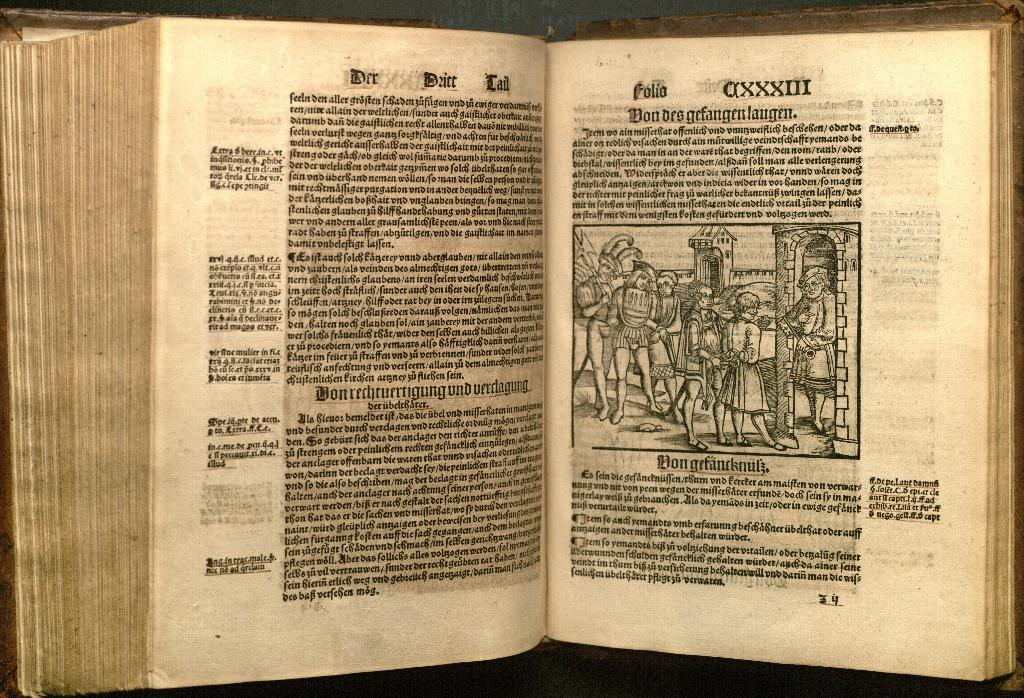<image>
Create a compact narrative representing the image presented. A photo of an ancient text of some kind that appears to be in ancient German or Italian. It appears to date to the 1st century. 